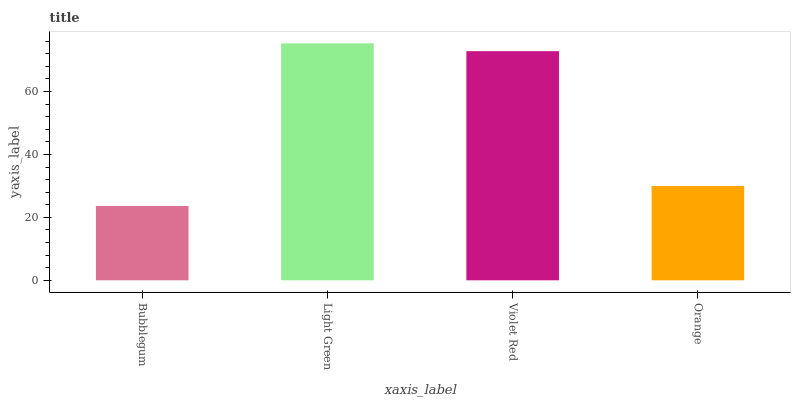Is Violet Red the minimum?
Answer yes or no. No. Is Violet Red the maximum?
Answer yes or no. No. Is Light Green greater than Violet Red?
Answer yes or no. Yes. Is Violet Red less than Light Green?
Answer yes or no. Yes. Is Violet Red greater than Light Green?
Answer yes or no. No. Is Light Green less than Violet Red?
Answer yes or no. No. Is Violet Red the high median?
Answer yes or no. Yes. Is Orange the low median?
Answer yes or no. Yes. Is Orange the high median?
Answer yes or no. No. Is Light Green the low median?
Answer yes or no. No. 